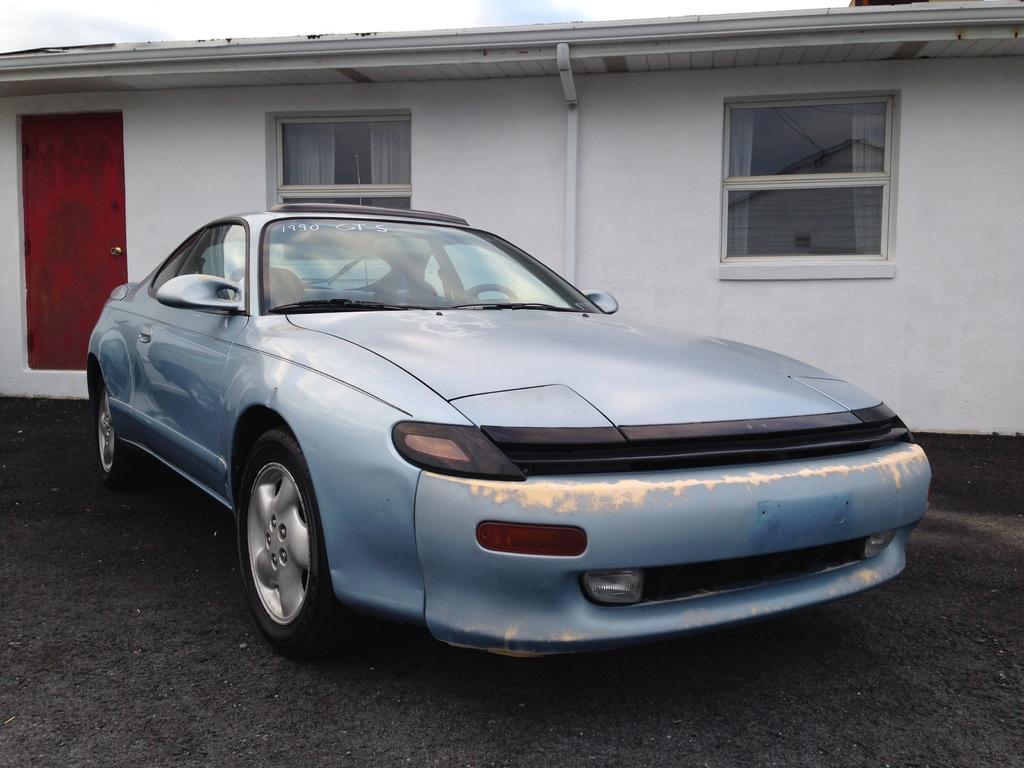Can you describe this image briefly? In the image in the center,we can see one car. In the background we can see the sky,clouds,windows,building,wall,pipe and door. 